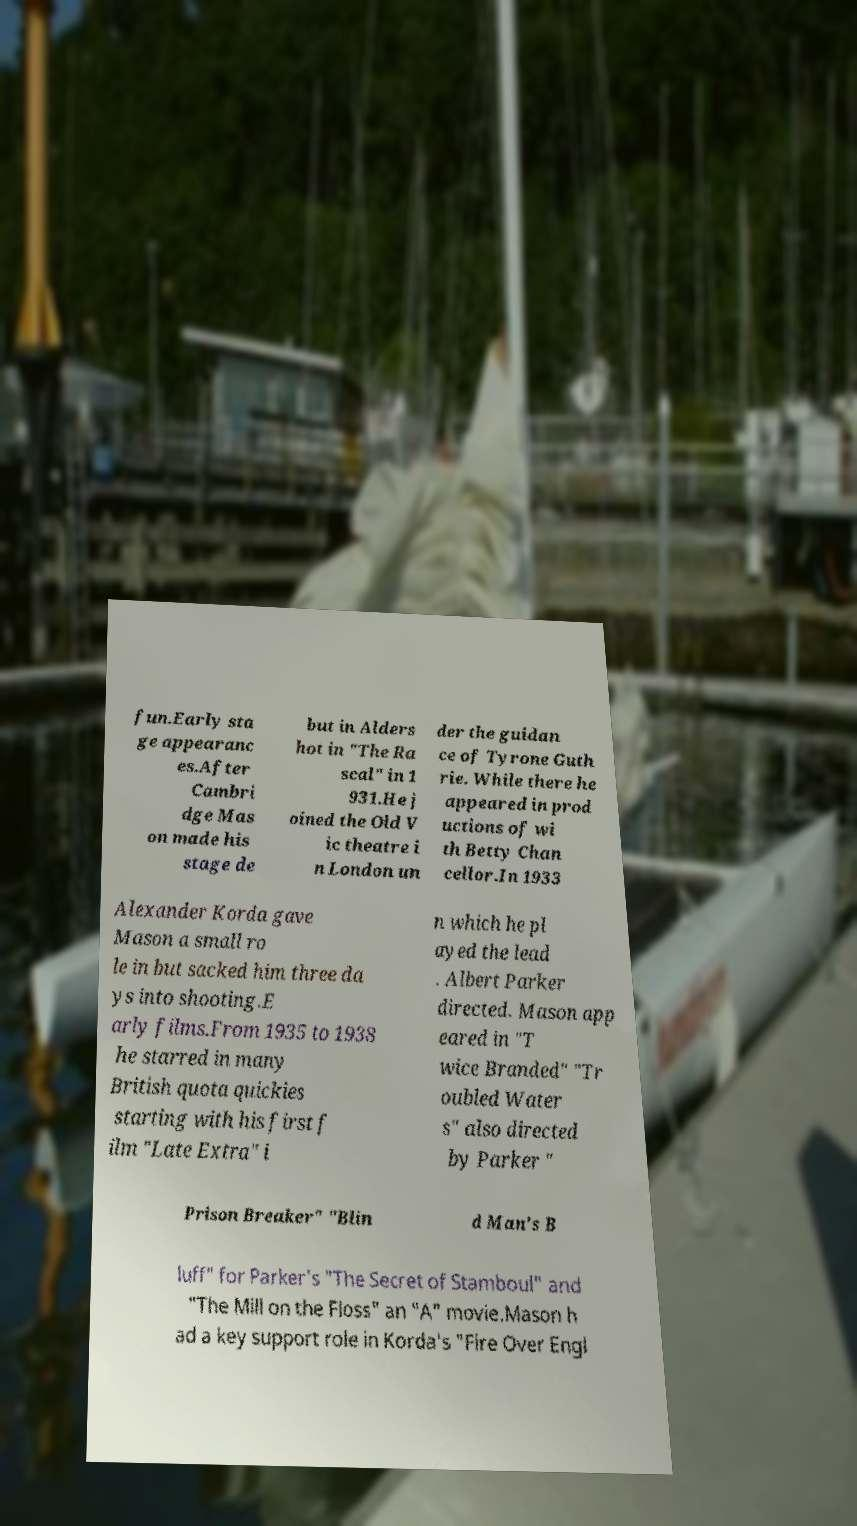There's text embedded in this image that I need extracted. Can you transcribe it verbatim? fun.Early sta ge appearanc es.After Cambri dge Mas on made his stage de but in Alders hot in "The Ra scal" in 1 931.He j oined the Old V ic theatre i n London un der the guidan ce of Tyrone Guth rie. While there he appeared in prod uctions of wi th Betty Chan cellor.In 1933 Alexander Korda gave Mason a small ro le in but sacked him three da ys into shooting.E arly films.From 1935 to 1938 he starred in many British quota quickies starting with his first f ilm "Late Extra" i n which he pl ayed the lead . Albert Parker directed. Mason app eared in "T wice Branded" "Tr oubled Water s" also directed by Parker " Prison Breaker" "Blin d Man's B luff" for Parker's "The Secret of Stamboul" and "The Mill on the Floss" an "A" movie.Mason h ad a key support role in Korda's "Fire Over Engl 